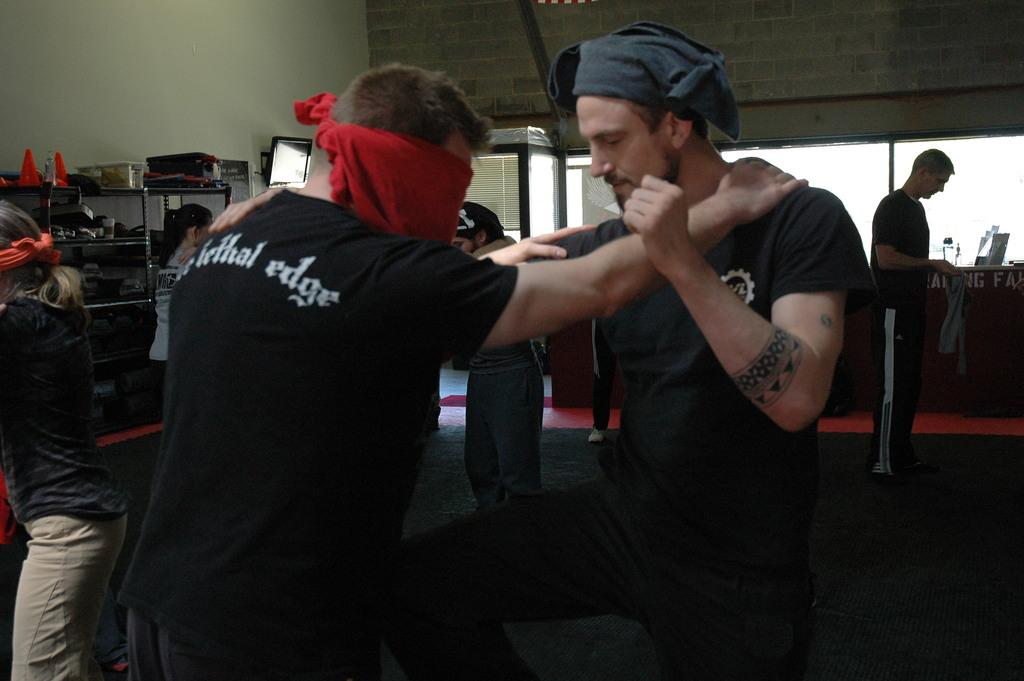Who or what can be seen in the image? There are people in the image. What part of the room is visible in the image? The floor is visible in the image. What can be seen in the background of the image? There are objects in racks, a television, a wall, and windows in the background. What type of coal is being used to cook the meal in the image? There is no coal or meal present in the image. 